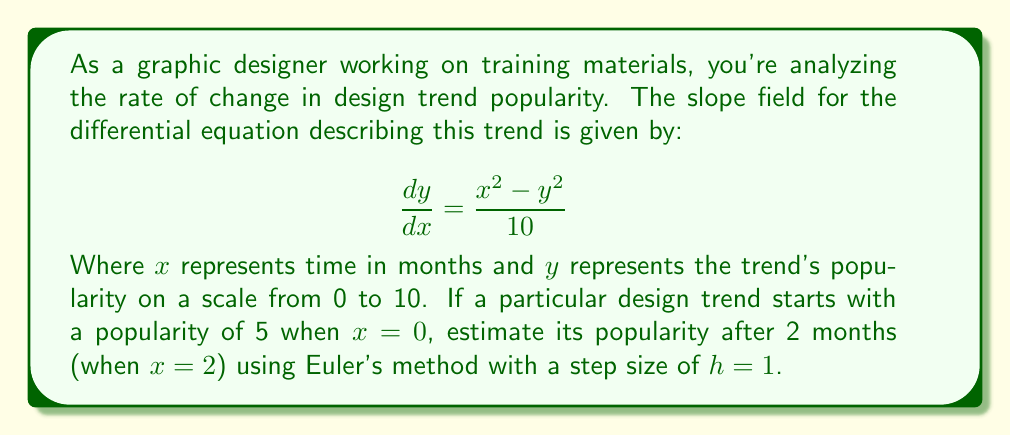Can you answer this question? To solve this problem using Euler's method, we'll follow these steps:

1) Euler's method is given by the formula:
   $$y_{n+1} = y_n + h \cdot f(x_n, y_n)$$
   where $f(x, y) = \frac{dy}{dx} = \frac{x^2 - y^2}{10}$

2) We start with $x_0 = 0$, $y_0 = 5$, and we need to calculate $y_2$ (after 2 steps of size $h = 1$)

3) First step ($n = 0$):
   $$\begin{align*}
   y_1 &= y_0 + h \cdot f(x_0, y_0) \\
   &= 5 + 1 \cdot \frac{0^2 - 5^2}{10} \\
   &= 5 - 2.5 = 2.5
   \end{align*}$$

4) Second step ($n = 1$):
   $$\begin{align*}
   y_2 &= y_1 + h \cdot f(x_1, y_1) \\
   &= 2.5 + 1 \cdot \frac{1^2 - 2.5^2}{10} \\
   &= 2.5 + \frac{1 - 6.25}{10} \\
   &= 2.5 - 0.525 = 1.975
   \end{align*}$$

Therefore, after 2 months, the estimated popularity of the design trend is approximately 1.975.
Answer: The estimated popularity of the design trend after 2 months is approximately 1.975 on a scale from 0 to 10. 